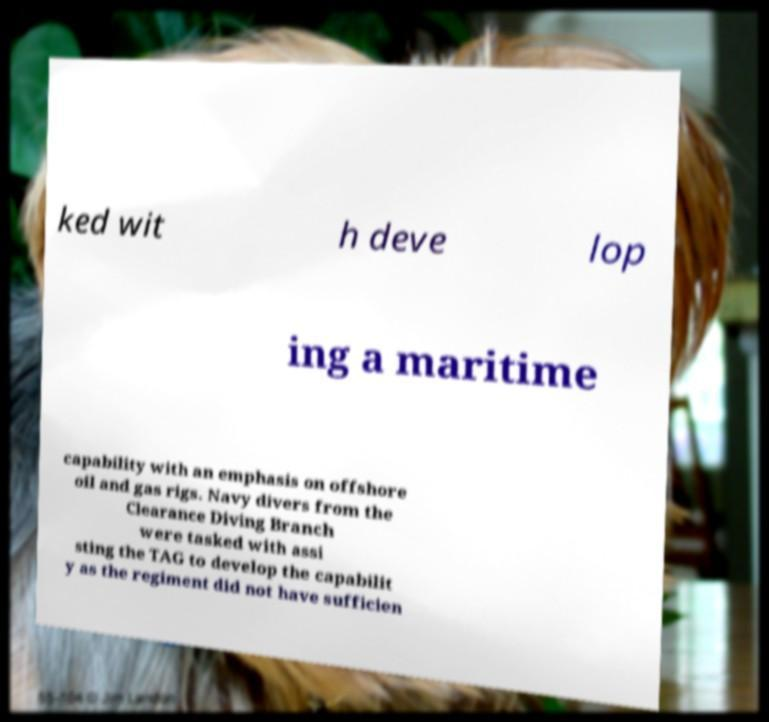Please identify and transcribe the text found in this image. ked wit h deve lop ing a maritime capability with an emphasis on offshore oil and gas rigs. Navy divers from the Clearance Diving Branch were tasked with assi sting the TAG to develop the capabilit y as the regiment did not have sufficien 